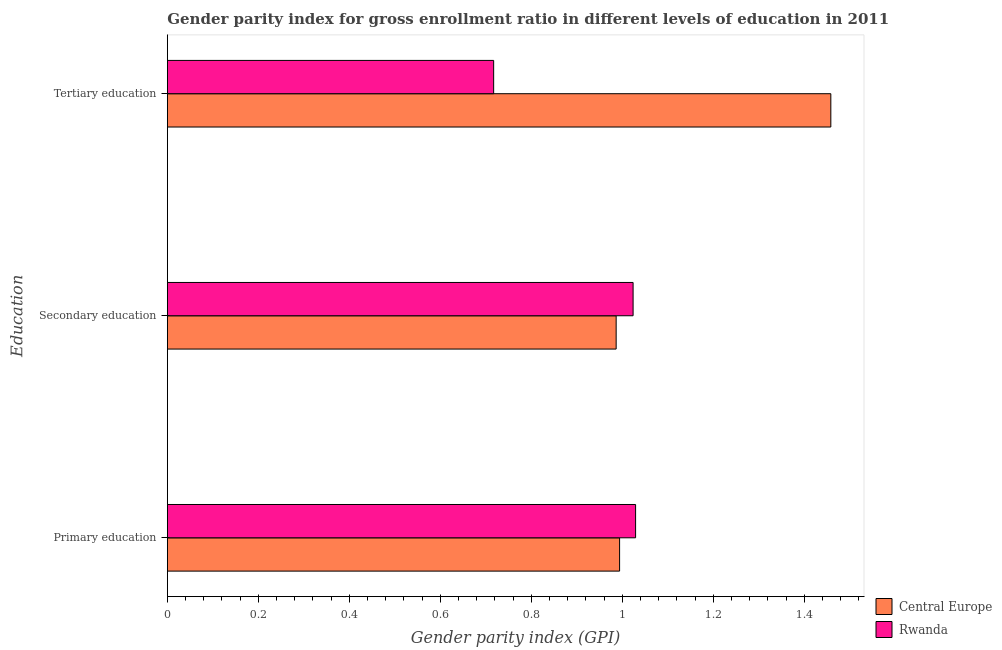How many different coloured bars are there?
Offer a very short reply. 2. How many groups of bars are there?
Your response must be concise. 3. Are the number of bars per tick equal to the number of legend labels?
Make the answer very short. Yes. How many bars are there on the 1st tick from the top?
Provide a short and direct response. 2. How many bars are there on the 1st tick from the bottom?
Provide a short and direct response. 2. What is the label of the 1st group of bars from the top?
Provide a short and direct response. Tertiary education. What is the gender parity index in primary education in Rwanda?
Offer a very short reply. 1.03. Across all countries, what is the maximum gender parity index in primary education?
Give a very brief answer. 1.03. Across all countries, what is the minimum gender parity index in tertiary education?
Give a very brief answer. 0.72. In which country was the gender parity index in tertiary education maximum?
Offer a terse response. Central Europe. In which country was the gender parity index in tertiary education minimum?
Keep it short and to the point. Rwanda. What is the total gender parity index in tertiary education in the graph?
Make the answer very short. 2.18. What is the difference between the gender parity index in secondary education in Central Europe and that in Rwanda?
Offer a very short reply. -0.04. What is the difference between the gender parity index in tertiary education in Central Europe and the gender parity index in primary education in Rwanda?
Ensure brevity in your answer.  0.43. What is the average gender parity index in primary education per country?
Make the answer very short. 1.01. What is the difference between the gender parity index in primary education and gender parity index in tertiary education in Rwanda?
Make the answer very short. 0.31. In how many countries, is the gender parity index in tertiary education greater than 0.56 ?
Your answer should be compact. 2. What is the ratio of the gender parity index in secondary education in Rwanda to that in Central Europe?
Your response must be concise. 1.04. What is the difference between the highest and the second highest gender parity index in primary education?
Offer a terse response. 0.04. What is the difference between the highest and the lowest gender parity index in secondary education?
Your answer should be very brief. 0.04. Is the sum of the gender parity index in tertiary education in Central Europe and Rwanda greater than the maximum gender parity index in primary education across all countries?
Your answer should be very brief. Yes. What does the 1st bar from the top in Tertiary education represents?
Offer a terse response. Rwanda. What does the 1st bar from the bottom in Tertiary education represents?
Ensure brevity in your answer.  Central Europe. Are all the bars in the graph horizontal?
Ensure brevity in your answer.  Yes. Are the values on the major ticks of X-axis written in scientific E-notation?
Your answer should be compact. No. How many legend labels are there?
Provide a short and direct response. 2. How are the legend labels stacked?
Make the answer very short. Vertical. What is the title of the graph?
Make the answer very short. Gender parity index for gross enrollment ratio in different levels of education in 2011. Does "Latin America(developing only)" appear as one of the legend labels in the graph?
Your answer should be compact. No. What is the label or title of the X-axis?
Make the answer very short. Gender parity index (GPI). What is the label or title of the Y-axis?
Keep it short and to the point. Education. What is the Gender parity index (GPI) of Central Europe in Primary education?
Your response must be concise. 0.99. What is the Gender parity index (GPI) of Rwanda in Primary education?
Your answer should be very brief. 1.03. What is the Gender parity index (GPI) of Central Europe in Secondary education?
Your answer should be very brief. 0.99. What is the Gender parity index (GPI) of Rwanda in Secondary education?
Provide a succinct answer. 1.02. What is the Gender parity index (GPI) of Central Europe in Tertiary education?
Provide a short and direct response. 1.46. What is the Gender parity index (GPI) in Rwanda in Tertiary education?
Your answer should be very brief. 0.72. Across all Education, what is the maximum Gender parity index (GPI) in Central Europe?
Provide a succinct answer. 1.46. Across all Education, what is the maximum Gender parity index (GPI) in Rwanda?
Keep it short and to the point. 1.03. Across all Education, what is the minimum Gender parity index (GPI) in Central Europe?
Give a very brief answer. 0.99. Across all Education, what is the minimum Gender parity index (GPI) in Rwanda?
Ensure brevity in your answer.  0.72. What is the total Gender parity index (GPI) of Central Europe in the graph?
Offer a very short reply. 3.44. What is the total Gender parity index (GPI) of Rwanda in the graph?
Your response must be concise. 2.77. What is the difference between the Gender parity index (GPI) in Central Europe in Primary education and that in Secondary education?
Ensure brevity in your answer.  0.01. What is the difference between the Gender parity index (GPI) in Rwanda in Primary education and that in Secondary education?
Your answer should be compact. 0.01. What is the difference between the Gender parity index (GPI) of Central Europe in Primary education and that in Tertiary education?
Make the answer very short. -0.46. What is the difference between the Gender parity index (GPI) in Rwanda in Primary education and that in Tertiary education?
Ensure brevity in your answer.  0.31. What is the difference between the Gender parity index (GPI) of Central Europe in Secondary education and that in Tertiary education?
Your answer should be compact. -0.47. What is the difference between the Gender parity index (GPI) in Rwanda in Secondary education and that in Tertiary education?
Make the answer very short. 0.31. What is the difference between the Gender parity index (GPI) in Central Europe in Primary education and the Gender parity index (GPI) in Rwanda in Secondary education?
Provide a succinct answer. -0.03. What is the difference between the Gender parity index (GPI) of Central Europe in Primary education and the Gender parity index (GPI) of Rwanda in Tertiary education?
Give a very brief answer. 0.28. What is the difference between the Gender parity index (GPI) in Central Europe in Secondary education and the Gender parity index (GPI) in Rwanda in Tertiary education?
Give a very brief answer. 0.27. What is the average Gender parity index (GPI) of Central Europe per Education?
Offer a terse response. 1.15. What is the average Gender parity index (GPI) of Rwanda per Education?
Make the answer very short. 0.92. What is the difference between the Gender parity index (GPI) of Central Europe and Gender parity index (GPI) of Rwanda in Primary education?
Keep it short and to the point. -0.04. What is the difference between the Gender parity index (GPI) in Central Europe and Gender parity index (GPI) in Rwanda in Secondary education?
Offer a terse response. -0.04. What is the difference between the Gender parity index (GPI) of Central Europe and Gender parity index (GPI) of Rwanda in Tertiary education?
Your answer should be very brief. 0.74. What is the ratio of the Gender parity index (GPI) of Central Europe in Primary education to that in Secondary education?
Offer a very short reply. 1.01. What is the ratio of the Gender parity index (GPI) in Rwanda in Primary education to that in Secondary education?
Offer a terse response. 1.01. What is the ratio of the Gender parity index (GPI) of Central Europe in Primary education to that in Tertiary education?
Your answer should be very brief. 0.68. What is the ratio of the Gender parity index (GPI) of Rwanda in Primary education to that in Tertiary education?
Ensure brevity in your answer.  1.44. What is the ratio of the Gender parity index (GPI) in Central Europe in Secondary education to that in Tertiary education?
Keep it short and to the point. 0.68. What is the ratio of the Gender parity index (GPI) in Rwanda in Secondary education to that in Tertiary education?
Make the answer very short. 1.43. What is the difference between the highest and the second highest Gender parity index (GPI) of Central Europe?
Ensure brevity in your answer.  0.46. What is the difference between the highest and the second highest Gender parity index (GPI) of Rwanda?
Give a very brief answer. 0.01. What is the difference between the highest and the lowest Gender parity index (GPI) in Central Europe?
Keep it short and to the point. 0.47. What is the difference between the highest and the lowest Gender parity index (GPI) of Rwanda?
Your answer should be compact. 0.31. 